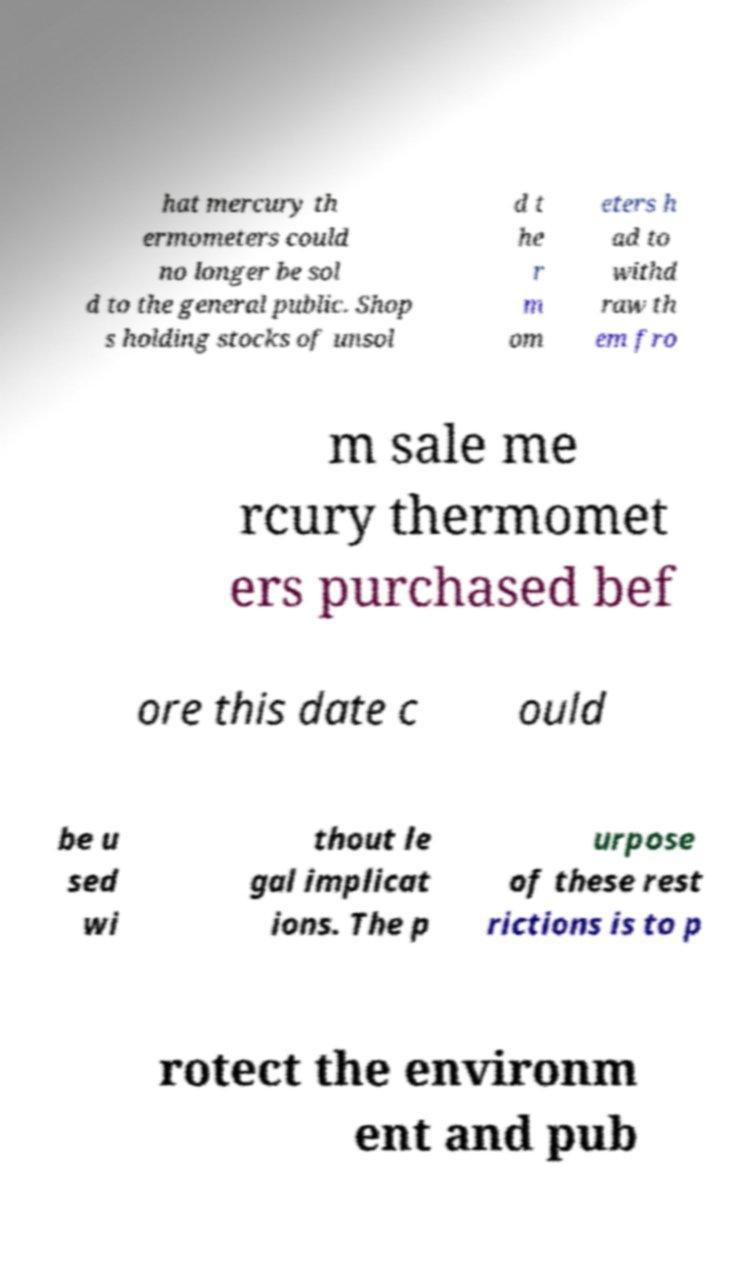I need the written content from this picture converted into text. Can you do that? hat mercury th ermometers could no longer be sol d to the general public. Shop s holding stocks of unsol d t he r m om eters h ad to withd raw th em fro m sale me rcury thermomet ers purchased bef ore this date c ould be u sed wi thout le gal implicat ions. The p urpose of these rest rictions is to p rotect the environm ent and pub 